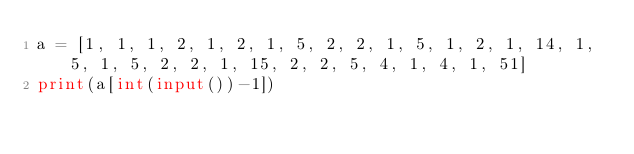<code> <loc_0><loc_0><loc_500><loc_500><_Python_>a = [1, 1, 1, 2, 1, 2, 1, 5, 2, 2, 1, 5, 1, 2, 1, 14, 1, 5, 1, 5, 2, 2, 1, 15, 2, 2, 5, 4, 1, 4, 1, 51]
print(a[int(input())-1])
</code> 